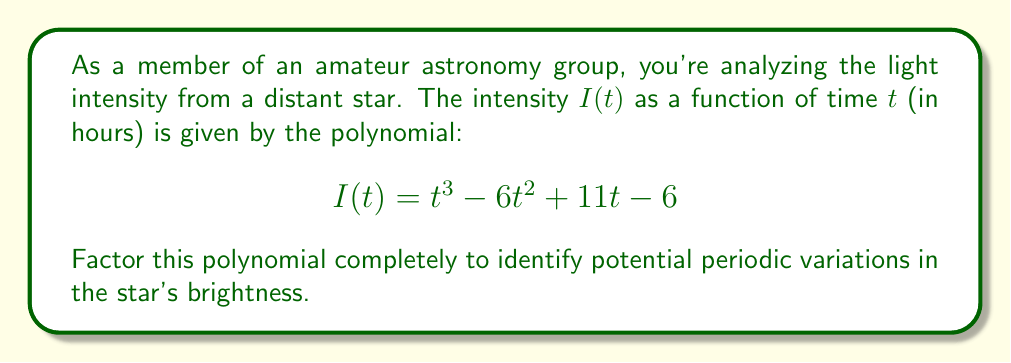Solve this math problem. To factor this cubic polynomial, we'll follow these steps:

1) First, let's check if there's a common factor. In this case, there isn't.

2) Next, we'll try to find a root. One way to do this is to use the rational root theorem. The possible rational roots are the factors of the constant term (±1, ±2, ±3, ±6). 

3) Testing these values, we find that $I(1) = 1 - 6 + 11 - 6 = 0$. So, $(t-1)$ is a factor.

4) We can use polynomial long division to find the other factor:

   $$\frac{t^3 - 6t^2 + 11t - 6}{t - 1} = t^2 - 5t + 6$$

5) Now we have: $I(t) = (t-1)(t^2 - 5t + 6)$

6) The quadratic factor $t^2 - 5t + 6$ can be factored further:
   
   $$t^2 - 5t + 6 = (t-2)(t-3)$$

7) Therefore, the complete factorization is:

   $$I(t) = (t-1)(t-2)(t-3)$$

This factorization reveals that the light intensity reaches zero at t = 1, 2, and 3 hours, which could indicate periodic dimming or an eclipse by a triple star system.
Answer: $I(t) = (t-1)(t-2)(t-3)$ 